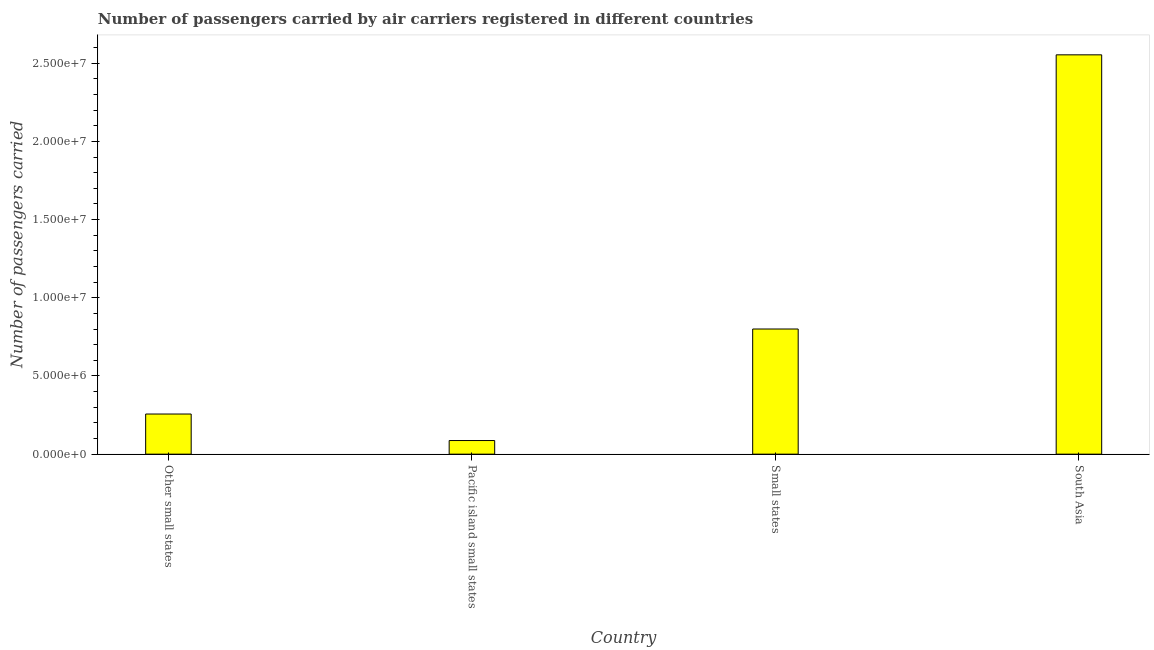Does the graph contain any zero values?
Offer a very short reply. No. What is the title of the graph?
Your response must be concise. Number of passengers carried by air carriers registered in different countries. What is the label or title of the X-axis?
Your answer should be very brief. Country. What is the label or title of the Y-axis?
Offer a very short reply. Number of passengers carried. What is the number of passengers carried in Other small states?
Your answer should be very brief. 2.57e+06. Across all countries, what is the maximum number of passengers carried?
Ensure brevity in your answer.  2.55e+07. Across all countries, what is the minimum number of passengers carried?
Ensure brevity in your answer.  8.72e+05. In which country was the number of passengers carried minimum?
Keep it short and to the point. Pacific island small states. What is the sum of the number of passengers carried?
Make the answer very short. 3.70e+07. What is the difference between the number of passengers carried in Other small states and South Asia?
Your response must be concise. -2.30e+07. What is the average number of passengers carried per country?
Keep it short and to the point. 9.25e+06. What is the median number of passengers carried?
Provide a succinct answer. 5.29e+06. What is the ratio of the number of passengers carried in Pacific island small states to that in South Asia?
Your response must be concise. 0.03. What is the difference between the highest and the second highest number of passengers carried?
Make the answer very short. 1.75e+07. Is the sum of the number of passengers carried in Pacific island small states and South Asia greater than the maximum number of passengers carried across all countries?
Offer a terse response. Yes. What is the difference between the highest and the lowest number of passengers carried?
Make the answer very short. 2.47e+07. Are all the bars in the graph horizontal?
Keep it short and to the point. No. How many countries are there in the graph?
Offer a very short reply. 4. What is the difference between two consecutive major ticks on the Y-axis?
Give a very brief answer. 5.00e+06. What is the Number of passengers carried in Other small states?
Provide a short and direct response. 2.57e+06. What is the Number of passengers carried in Pacific island small states?
Provide a succinct answer. 8.72e+05. What is the Number of passengers carried in Small states?
Provide a short and direct response. 8.00e+06. What is the Number of passengers carried of South Asia?
Offer a terse response. 2.55e+07. What is the difference between the Number of passengers carried in Other small states and Pacific island small states?
Provide a succinct answer. 1.70e+06. What is the difference between the Number of passengers carried in Other small states and Small states?
Provide a short and direct response. -5.44e+06. What is the difference between the Number of passengers carried in Other small states and South Asia?
Your answer should be compact. -2.30e+07. What is the difference between the Number of passengers carried in Pacific island small states and Small states?
Ensure brevity in your answer.  -7.13e+06. What is the difference between the Number of passengers carried in Pacific island small states and South Asia?
Make the answer very short. -2.47e+07. What is the difference between the Number of passengers carried in Small states and South Asia?
Your response must be concise. -1.75e+07. What is the ratio of the Number of passengers carried in Other small states to that in Pacific island small states?
Give a very brief answer. 2.94. What is the ratio of the Number of passengers carried in Other small states to that in Small states?
Offer a terse response. 0.32. What is the ratio of the Number of passengers carried in Other small states to that in South Asia?
Make the answer very short. 0.1. What is the ratio of the Number of passengers carried in Pacific island small states to that in Small states?
Ensure brevity in your answer.  0.11. What is the ratio of the Number of passengers carried in Pacific island small states to that in South Asia?
Ensure brevity in your answer.  0.03. What is the ratio of the Number of passengers carried in Small states to that in South Asia?
Ensure brevity in your answer.  0.31. 